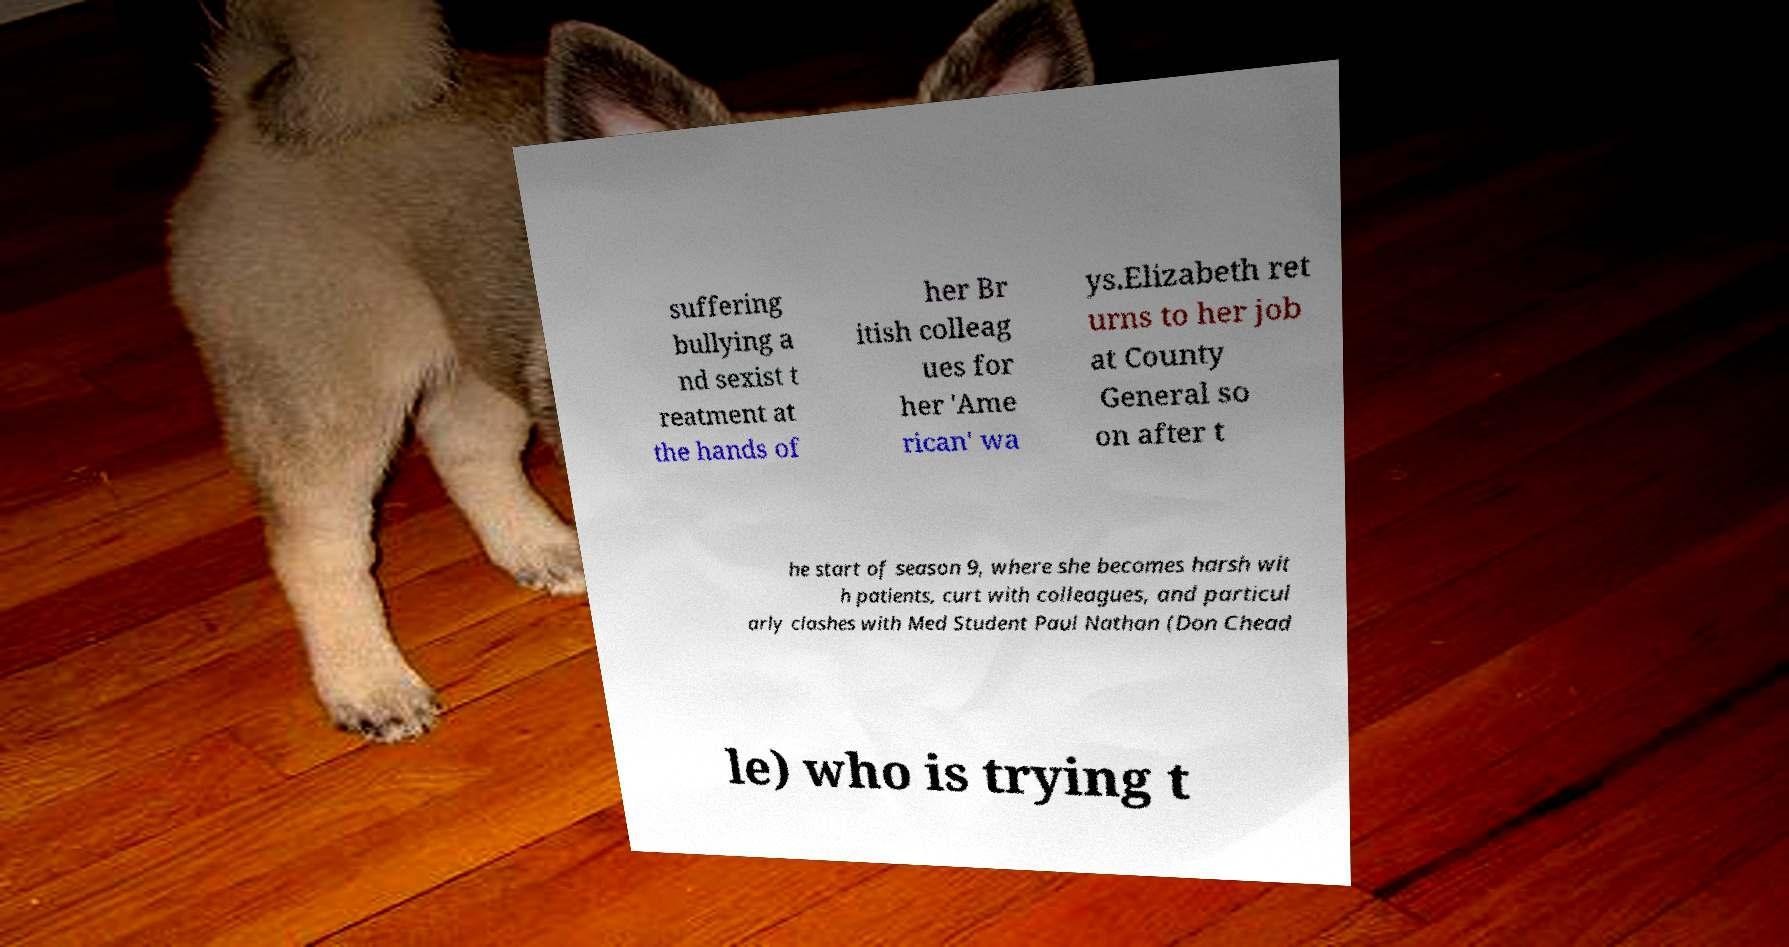Please identify and transcribe the text found in this image. suffering bullying a nd sexist t reatment at the hands of her Br itish colleag ues for her 'Ame rican' wa ys.Elizabeth ret urns to her job at County General so on after t he start of season 9, where she becomes harsh wit h patients, curt with colleagues, and particul arly clashes with Med Student Paul Nathan (Don Chead le) who is trying t 